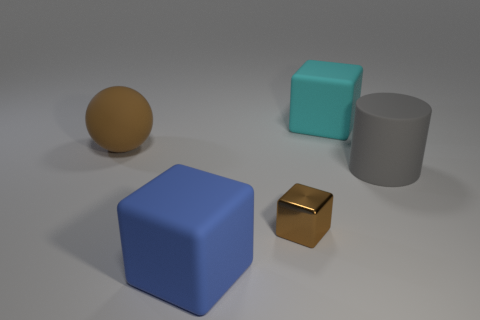The big thing that is both to the left of the tiny brown block and to the right of the rubber sphere is what color? blue 